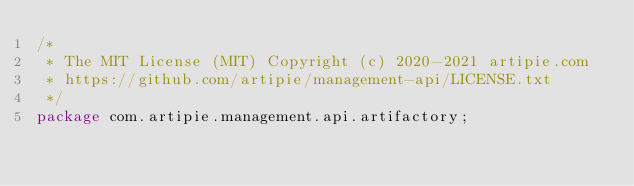<code> <loc_0><loc_0><loc_500><loc_500><_Java_>/*
 * The MIT License (MIT) Copyright (c) 2020-2021 artipie.com
 * https://github.com/artipie/management-api/LICENSE.txt
 */
package com.artipie.management.api.artifactory;
</code> 